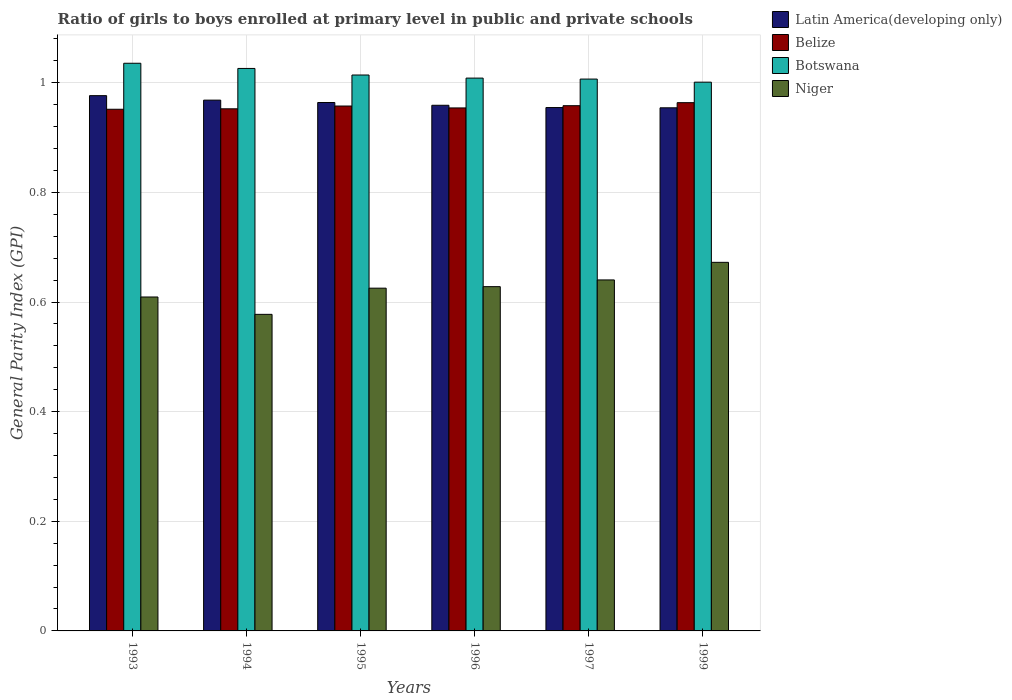How many groups of bars are there?
Make the answer very short. 6. Are the number of bars per tick equal to the number of legend labels?
Give a very brief answer. Yes. In how many cases, is the number of bars for a given year not equal to the number of legend labels?
Keep it short and to the point. 0. What is the general parity index in Latin America(developing only) in 1996?
Your response must be concise. 0.96. Across all years, what is the maximum general parity index in Niger?
Provide a short and direct response. 0.67. Across all years, what is the minimum general parity index in Botswana?
Keep it short and to the point. 1. What is the total general parity index in Latin America(developing only) in the graph?
Your response must be concise. 5.78. What is the difference between the general parity index in Botswana in 1993 and that in 1996?
Keep it short and to the point. 0.03. What is the difference between the general parity index in Niger in 1994 and the general parity index in Belize in 1995?
Offer a terse response. -0.38. What is the average general parity index in Botswana per year?
Keep it short and to the point. 1.02. In the year 1995, what is the difference between the general parity index in Botswana and general parity index in Latin America(developing only)?
Provide a succinct answer. 0.05. In how many years, is the general parity index in Niger greater than 0.32?
Provide a short and direct response. 6. What is the ratio of the general parity index in Latin America(developing only) in 1994 to that in 1999?
Offer a terse response. 1.01. Is the general parity index in Latin America(developing only) in 1993 less than that in 1996?
Offer a terse response. No. Is the difference between the general parity index in Botswana in 1994 and 1999 greater than the difference between the general parity index in Latin America(developing only) in 1994 and 1999?
Your response must be concise. Yes. What is the difference between the highest and the second highest general parity index in Niger?
Keep it short and to the point. 0.03. What is the difference between the highest and the lowest general parity index in Niger?
Your response must be concise. 0.09. Is it the case that in every year, the sum of the general parity index in Belize and general parity index in Botswana is greater than the sum of general parity index in Niger and general parity index in Latin America(developing only)?
Ensure brevity in your answer.  Yes. What does the 4th bar from the left in 1994 represents?
Offer a very short reply. Niger. What does the 2nd bar from the right in 1995 represents?
Give a very brief answer. Botswana. Is it the case that in every year, the sum of the general parity index in Belize and general parity index in Botswana is greater than the general parity index in Niger?
Provide a succinct answer. Yes. Are all the bars in the graph horizontal?
Make the answer very short. No. Does the graph contain grids?
Offer a very short reply. Yes. How are the legend labels stacked?
Your response must be concise. Vertical. What is the title of the graph?
Offer a very short reply. Ratio of girls to boys enrolled at primary level in public and private schools. Does "Europe(developing only)" appear as one of the legend labels in the graph?
Your answer should be compact. No. What is the label or title of the X-axis?
Keep it short and to the point. Years. What is the label or title of the Y-axis?
Make the answer very short. General Parity Index (GPI). What is the General Parity Index (GPI) of Latin America(developing only) in 1993?
Your answer should be very brief. 0.98. What is the General Parity Index (GPI) of Belize in 1993?
Offer a very short reply. 0.95. What is the General Parity Index (GPI) in Botswana in 1993?
Your answer should be very brief. 1.04. What is the General Parity Index (GPI) in Niger in 1993?
Keep it short and to the point. 0.61. What is the General Parity Index (GPI) in Latin America(developing only) in 1994?
Provide a succinct answer. 0.97. What is the General Parity Index (GPI) of Belize in 1994?
Provide a short and direct response. 0.95. What is the General Parity Index (GPI) in Botswana in 1994?
Give a very brief answer. 1.03. What is the General Parity Index (GPI) in Niger in 1994?
Make the answer very short. 0.58. What is the General Parity Index (GPI) in Latin America(developing only) in 1995?
Keep it short and to the point. 0.96. What is the General Parity Index (GPI) in Belize in 1995?
Your answer should be compact. 0.96. What is the General Parity Index (GPI) in Botswana in 1995?
Offer a very short reply. 1.01. What is the General Parity Index (GPI) in Niger in 1995?
Ensure brevity in your answer.  0.63. What is the General Parity Index (GPI) of Latin America(developing only) in 1996?
Offer a very short reply. 0.96. What is the General Parity Index (GPI) of Belize in 1996?
Give a very brief answer. 0.95. What is the General Parity Index (GPI) of Botswana in 1996?
Ensure brevity in your answer.  1.01. What is the General Parity Index (GPI) of Niger in 1996?
Your answer should be compact. 0.63. What is the General Parity Index (GPI) in Latin America(developing only) in 1997?
Make the answer very short. 0.95. What is the General Parity Index (GPI) in Belize in 1997?
Give a very brief answer. 0.96. What is the General Parity Index (GPI) in Botswana in 1997?
Your answer should be compact. 1.01. What is the General Parity Index (GPI) of Niger in 1997?
Offer a very short reply. 0.64. What is the General Parity Index (GPI) of Latin America(developing only) in 1999?
Your answer should be very brief. 0.95. What is the General Parity Index (GPI) of Belize in 1999?
Offer a terse response. 0.96. What is the General Parity Index (GPI) of Botswana in 1999?
Offer a very short reply. 1. What is the General Parity Index (GPI) in Niger in 1999?
Your answer should be very brief. 0.67. Across all years, what is the maximum General Parity Index (GPI) in Latin America(developing only)?
Your response must be concise. 0.98. Across all years, what is the maximum General Parity Index (GPI) of Belize?
Ensure brevity in your answer.  0.96. Across all years, what is the maximum General Parity Index (GPI) in Botswana?
Provide a succinct answer. 1.04. Across all years, what is the maximum General Parity Index (GPI) of Niger?
Your answer should be very brief. 0.67. Across all years, what is the minimum General Parity Index (GPI) in Latin America(developing only)?
Offer a terse response. 0.95. Across all years, what is the minimum General Parity Index (GPI) of Belize?
Give a very brief answer. 0.95. Across all years, what is the minimum General Parity Index (GPI) of Botswana?
Your response must be concise. 1. Across all years, what is the minimum General Parity Index (GPI) of Niger?
Your answer should be compact. 0.58. What is the total General Parity Index (GPI) in Latin America(developing only) in the graph?
Keep it short and to the point. 5.78. What is the total General Parity Index (GPI) in Belize in the graph?
Ensure brevity in your answer.  5.74. What is the total General Parity Index (GPI) in Botswana in the graph?
Your response must be concise. 6.09. What is the total General Parity Index (GPI) of Niger in the graph?
Ensure brevity in your answer.  3.75. What is the difference between the General Parity Index (GPI) in Latin America(developing only) in 1993 and that in 1994?
Your response must be concise. 0.01. What is the difference between the General Parity Index (GPI) in Belize in 1993 and that in 1994?
Provide a short and direct response. -0. What is the difference between the General Parity Index (GPI) in Botswana in 1993 and that in 1994?
Offer a very short reply. 0.01. What is the difference between the General Parity Index (GPI) of Niger in 1993 and that in 1994?
Your answer should be very brief. 0.03. What is the difference between the General Parity Index (GPI) in Latin America(developing only) in 1993 and that in 1995?
Your answer should be very brief. 0.01. What is the difference between the General Parity Index (GPI) of Belize in 1993 and that in 1995?
Your answer should be very brief. -0.01. What is the difference between the General Parity Index (GPI) in Botswana in 1993 and that in 1995?
Offer a very short reply. 0.02. What is the difference between the General Parity Index (GPI) in Niger in 1993 and that in 1995?
Keep it short and to the point. -0.02. What is the difference between the General Parity Index (GPI) in Latin America(developing only) in 1993 and that in 1996?
Offer a terse response. 0.02. What is the difference between the General Parity Index (GPI) in Belize in 1993 and that in 1996?
Offer a terse response. -0. What is the difference between the General Parity Index (GPI) of Botswana in 1993 and that in 1996?
Provide a short and direct response. 0.03. What is the difference between the General Parity Index (GPI) of Niger in 1993 and that in 1996?
Your response must be concise. -0.02. What is the difference between the General Parity Index (GPI) in Latin America(developing only) in 1993 and that in 1997?
Ensure brevity in your answer.  0.02. What is the difference between the General Parity Index (GPI) of Belize in 1993 and that in 1997?
Provide a succinct answer. -0.01. What is the difference between the General Parity Index (GPI) in Botswana in 1993 and that in 1997?
Your answer should be compact. 0.03. What is the difference between the General Parity Index (GPI) of Niger in 1993 and that in 1997?
Offer a terse response. -0.03. What is the difference between the General Parity Index (GPI) in Latin America(developing only) in 1993 and that in 1999?
Your answer should be compact. 0.02. What is the difference between the General Parity Index (GPI) of Belize in 1993 and that in 1999?
Provide a short and direct response. -0.01. What is the difference between the General Parity Index (GPI) in Botswana in 1993 and that in 1999?
Your answer should be very brief. 0.03. What is the difference between the General Parity Index (GPI) of Niger in 1993 and that in 1999?
Offer a terse response. -0.06. What is the difference between the General Parity Index (GPI) in Latin America(developing only) in 1994 and that in 1995?
Your answer should be very brief. 0. What is the difference between the General Parity Index (GPI) in Belize in 1994 and that in 1995?
Make the answer very short. -0.01. What is the difference between the General Parity Index (GPI) of Botswana in 1994 and that in 1995?
Keep it short and to the point. 0.01. What is the difference between the General Parity Index (GPI) in Niger in 1994 and that in 1995?
Keep it short and to the point. -0.05. What is the difference between the General Parity Index (GPI) in Latin America(developing only) in 1994 and that in 1996?
Your answer should be very brief. 0.01. What is the difference between the General Parity Index (GPI) of Belize in 1994 and that in 1996?
Keep it short and to the point. -0. What is the difference between the General Parity Index (GPI) in Botswana in 1994 and that in 1996?
Your answer should be very brief. 0.02. What is the difference between the General Parity Index (GPI) of Niger in 1994 and that in 1996?
Your response must be concise. -0.05. What is the difference between the General Parity Index (GPI) of Latin America(developing only) in 1994 and that in 1997?
Provide a succinct answer. 0.01. What is the difference between the General Parity Index (GPI) of Belize in 1994 and that in 1997?
Your response must be concise. -0.01. What is the difference between the General Parity Index (GPI) of Botswana in 1994 and that in 1997?
Make the answer very short. 0.02. What is the difference between the General Parity Index (GPI) in Niger in 1994 and that in 1997?
Your response must be concise. -0.06. What is the difference between the General Parity Index (GPI) in Latin America(developing only) in 1994 and that in 1999?
Your response must be concise. 0.01. What is the difference between the General Parity Index (GPI) in Belize in 1994 and that in 1999?
Give a very brief answer. -0.01. What is the difference between the General Parity Index (GPI) in Botswana in 1994 and that in 1999?
Offer a terse response. 0.03. What is the difference between the General Parity Index (GPI) of Niger in 1994 and that in 1999?
Provide a short and direct response. -0.09. What is the difference between the General Parity Index (GPI) in Latin America(developing only) in 1995 and that in 1996?
Give a very brief answer. 0.01. What is the difference between the General Parity Index (GPI) in Belize in 1995 and that in 1996?
Keep it short and to the point. 0. What is the difference between the General Parity Index (GPI) in Botswana in 1995 and that in 1996?
Make the answer very short. 0.01. What is the difference between the General Parity Index (GPI) in Niger in 1995 and that in 1996?
Your answer should be very brief. -0. What is the difference between the General Parity Index (GPI) in Latin America(developing only) in 1995 and that in 1997?
Your answer should be very brief. 0.01. What is the difference between the General Parity Index (GPI) in Belize in 1995 and that in 1997?
Your answer should be compact. -0. What is the difference between the General Parity Index (GPI) of Botswana in 1995 and that in 1997?
Provide a succinct answer. 0.01. What is the difference between the General Parity Index (GPI) in Niger in 1995 and that in 1997?
Your response must be concise. -0.01. What is the difference between the General Parity Index (GPI) in Latin America(developing only) in 1995 and that in 1999?
Offer a very short reply. 0.01. What is the difference between the General Parity Index (GPI) of Belize in 1995 and that in 1999?
Your response must be concise. -0.01. What is the difference between the General Parity Index (GPI) in Botswana in 1995 and that in 1999?
Offer a terse response. 0.01. What is the difference between the General Parity Index (GPI) in Niger in 1995 and that in 1999?
Ensure brevity in your answer.  -0.05. What is the difference between the General Parity Index (GPI) of Latin America(developing only) in 1996 and that in 1997?
Offer a terse response. 0. What is the difference between the General Parity Index (GPI) of Belize in 1996 and that in 1997?
Offer a very short reply. -0. What is the difference between the General Parity Index (GPI) in Botswana in 1996 and that in 1997?
Make the answer very short. 0. What is the difference between the General Parity Index (GPI) in Niger in 1996 and that in 1997?
Keep it short and to the point. -0.01. What is the difference between the General Parity Index (GPI) of Latin America(developing only) in 1996 and that in 1999?
Your answer should be very brief. 0. What is the difference between the General Parity Index (GPI) in Belize in 1996 and that in 1999?
Offer a terse response. -0.01. What is the difference between the General Parity Index (GPI) in Botswana in 1996 and that in 1999?
Give a very brief answer. 0.01. What is the difference between the General Parity Index (GPI) in Niger in 1996 and that in 1999?
Your answer should be very brief. -0.04. What is the difference between the General Parity Index (GPI) of Belize in 1997 and that in 1999?
Give a very brief answer. -0.01. What is the difference between the General Parity Index (GPI) in Botswana in 1997 and that in 1999?
Provide a succinct answer. 0.01. What is the difference between the General Parity Index (GPI) in Niger in 1997 and that in 1999?
Make the answer very short. -0.03. What is the difference between the General Parity Index (GPI) of Latin America(developing only) in 1993 and the General Parity Index (GPI) of Belize in 1994?
Offer a very short reply. 0.02. What is the difference between the General Parity Index (GPI) of Latin America(developing only) in 1993 and the General Parity Index (GPI) of Botswana in 1994?
Your answer should be very brief. -0.05. What is the difference between the General Parity Index (GPI) of Latin America(developing only) in 1993 and the General Parity Index (GPI) of Niger in 1994?
Provide a succinct answer. 0.4. What is the difference between the General Parity Index (GPI) of Belize in 1993 and the General Parity Index (GPI) of Botswana in 1994?
Offer a very short reply. -0.07. What is the difference between the General Parity Index (GPI) of Belize in 1993 and the General Parity Index (GPI) of Niger in 1994?
Your response must be concise. 0.37. What is the difference between the General Parity Index (GPI) in Botswana in 1993 and the General Parity Index (GPI) in Niger in 1994?
Your answer should be compact. 0.46. What is the difference between the General Parity Index (GPI) of Latin America(developing only) in 1993 and the General Parity Index (GPI) of Belize in 1995?
Provide a short and direct response. 0.02. What is the difference between the General Parity Index (GPI) in Latin America(developing only) in 1993 and the General Parity Index (GPI) in Botswana in 1995?
Give a very brief answer. -0.04. What is the difference between the General Parity Index (GPI) of Latin America(developing only) in 1993 and the General Parity Index (GPI) of Niger in 1995?
Your response must be concise. 0.35. What is the difference between the General Parity Index (GPI) of Belize in 1993 and the General Parity Index (GPI) of Botswana in 1995?
Keep it short and to the point. -0.06. What is the difference between the General Parity Index (GPI) in Belize in 1993 and the General Parity Index (GPI) in Niger in 1995?
Give a very brief answer. 0.33. What is the difference between the General Parity Index (GPI) of Botswana in 1993 and the General Parity Index (GPI) of Niger in 1995?
Offer a very short reply. 0.41. What is the difference between the General Parity Index (GPI) of Latin America(developing only) in 1993 and the General Parity Index (GPI) of Belize in 1996?
Make the answer very short. 0.02. What is the difference between the General Parity Index (GPI) in Latin America(developing only) in 1993 and the General Parity Index (GPI) in Botswana in 1996?
Offer a very short reply. -0.03. What is the difference between the General Parity Index (GPI) of Latin America(developing only) in 1993 and the General Parity Index (GPI) of Niger in 1996?
Keep it short and to the point. 0.35. What is the difference between the General Parity Index (GPI) of Belize in 1993 and the General Parity Index (GPI) of Botswana in 1996?
Provide a succinct answer. -0.06. What is the difference between the General Parity Index (GPI) of Belize in 1993 and the General Parity Index (GPI) of Niger in 1996?
Your answer should be very brief. 0.32. What is the difference between the General Parity Index (GPI) in Botswana in 1993 and the General Parity Index (GPI) in Niger in 1996?
Provide a succinct answer. 0.41. What is the difference between the General Parity Index (GPI) in Latin America(developing only) in 1993 and the General Parity Index (GPI) in Belize in 1997?
Provide a short and direct response. 0.02. What is the difference between the General Parity Index (GPI) of Latin America(developing only) in 1993 and the General Parity Index (GPI) of Botswana in 1997?
Give a very brief answer. -0.03. What is the difference between the General Parity Index (GPI) of Latin America(developing only) in 1993 and the General Parity Index (GPI) of Niger in 1997?
Your answer should be compact. 0.34. What is the difference between the General Parity Index (GPI) in Belize in 1993 and the General Parity Index (GPI) in Botswana in 1997?
Provide a succinct answer. -0.06. What is the difference between the General Parity Index (GPI) of Belize in 1993 and the General Parity Index (GPI) of Niger in 1997?
Your answer should be very brief. 0.31. What is the difference between the General Parity Index (GPI) of Botswana in 1993 and the General Parity Index (GPI) of Niger in 1997?
Offer a very short reply. 0.4. What is the difference between the General Parity Index (GPI) in Latin America(developing only) in 1993 and the General Parity Index (GPI) in Belize in 1999?
Provide a short and direct response. 0.01. What is the difference between the General Parity Index (GPI) of Latin America(developing only) in 1993 and the General Parity Index (GPI) of Botswana in 1999?
Make the answer very short. -0.02. What is the difference between the General Parity Index (GPI) of Latin America(developing only) in 1993 and the General Parity Index (GPI) of Niger in 1999?
Offer a very short reply. 0.3. What is the difference between the General Parity Index (GPI) in Belize in 1993 and the General Parity Index (GPI) in Botswana in 1999?
Offer a very short reply. -0.05. What is the difference between the General Parity Index (GPI) of Belize in 1993 and the General Parity Index (GPI) of Niger in 1999?
Your answer should be compact. 0.28. What is the difference between the General Parity Index (GPI) of Botswana in 1993 and the General Parity Index (GPI) of Niger in 1999?
Your answer should be very brief. 0.36. What is the difference between the General Parity Index (GPI) in Latin America(developing only) in 1994 and the General Parity Index (GPI) in Belize in 1995?
Make the answer very short. 0.01. What is the difference between the General Parity Index (GPI) of Latin America(developing only) in 1994 and the General Parity Index (GPI) of Botswana in 1995?
Ensure brevity in your answer.  -0.05. What is the difference between the General Parity Index (GPI) of Latin America(developing only) in 1994 and the General Parity Index (GPI) of Niger in 1995?
Provide a succinct answer. 0.34. What is the difference between the General Parity Index (GPI) of Belize in 1994 and the General Parity Index (GPI) of Botswana in 1995?
Offer a very short reply. -0.06. What is the difference between the General Parity Index (GPI) of Belize in 1994 and the General Parity Index (GPI) of Niger in 1995?
Keep it short and to the point. 0.33. What is the difference between the General Parity Index (GPI) in Botswana in 1994 and the General Parity Index (GPI) in Niger in 1995?
Make the answer very short. 0.4. What is the difference between the General Parity Index (GPI) of Latin America(developing only) in 1994 and the General Parity Index (GPI) of Belize in 1996?
Provide a succinct answer. 0.01. What is the difference between the General Parity Index (GPI) of Latin America(developing only) in 1994 and the General Parity Index (GPI) of Botswana in 1996?
Offer a terse response. -0.04. What is the difference between the General Parity Index (GPI) in Latin America(developing only) in 1994 and the General Parity Index (GPI) in Niger in 1996?
Offer a very short reply. 0.34. What is the difference between the General Parity Index (GPI) of Belize in 1994 and the General Parity Index (GPI) of Botswana in 1996?
Ensure brevity in your answer.  -0.06. What is the difference between the General Parity Index (GPI) in Belize in 1994 and the General Parity Index (GPI) in Niger in 1996?
Ensure brevity in your answer.  0.32. What is the difference between the General Parity Index (GPI) of Botswana in 1994 and the General Parity Index (GPI) of Niger in 1996?
Ensure brevity in your answer.  0.4. What is the difference between the General Parity Index (GPI) in Latin America(developing only) in 1994 and the General Parity Index (GPI) in Belize in 1997?
Provide a succinct answer. 0.01. What is the difference between the General Parity Index (GPI) of Latin America(developing only) in 1994 and the General Parity Index (GPI) of Botswana in 1997?
Ensure brevity in your answer.  -0.04. What is the difference between the General Parity Index (GPI) in Latin America(developing only) in 1994 and the General Parity Index (GPI) in Niger in 1997?
Provide a succinct answer. 0.33. What is the difference between the General Parity Index (GPI) in Belize in 1994 and the General Parity Index (GPI) in Botswana in 1997?
Provide a succinct answer. -0.05. What is the difference between the General Parity Index (GPI) in Belize in 1994 and the General Parity Index (GPI) in Niger in 1997?
Keep it short and to the point. 0.31. What is the difference between the General Parity Index (GPI) in Botswana in 1994 and the General Parity Index (GPI) in Niger in 1997?
Offer a terse response. 0.39. What is the difference between the General Parity Index (GPI) in Latin America(developing only) in 1994 and the General Parity Index (GPI) in Belize in 1999?
Your answer should be compact. 0. What is the difference between the General Parity Index (GPI) of Latin America(developing only) in 1994 and the General Parity Index (GPI) of Botswana in 1999?
Offer a very short reply. -0.03. What is the difference between the General Parity Index (GPI) in Latin America(developing only) in 1994 and the General Parity Index (GPI) in Niger in 1999?
Make the answer very short. 0.3. What is the difference between the General Parity Index (GPI) of Belize in 1994 and the General Parity Index (GPI) of Botswana in 1999?
Keep it short and to the point. -0.05. What is the difference between the General Parity Index (GPI) of Belize in 1994 and the General Parity Index (GPI) of Niger in 1999?
Your answer should be very brief. 0.28. What is the difference between the General Parity Index (GPI) in Botswana in 1994 and the General Parity Index (GPI) in Niger in 1999?
Offer a terse response. 0.35. What is the difference between the General Parity Index (GPI) in Latin America(developing only) in 1995 and the General Parity Index (GPI) in Belize in 1996?
Your answer should be very brief. 0.01. What is the difference between the General Parity Index (GPI) of Latin America(developing only) in 1995 and the General Parity Index (GPI) of Botswana in 1996?
Your answer should be very brief. -0.04. What is the difference between the General Parity Index (GPI) in Latin America(developing only) in 1995 and the General Parity Index (GPI) in Niger in 1996?
Offer a very short reply. 0.34. What is the difference between the General Parity Index (GPI) in Belize in 1995 and the General Parity Index (GPI) in Botswana in 1996?
Offer a terse response. -0.05. What is the difference between the General Parity Index (GPI) of Belize in 1995 and the General Parity Index (GPI) of Niger in 1996?
Keep it short and to the point. 0.33. What is the difference between the General Parity Index (GPI) in Botswana in 1995 and the General Parity Index (GPI) in Niger in 1996?
Offer a very short reply. 0.39. What is the difference between the General Parity Index (GPI) in Latin America(developing only) in 1995 and the General Parity Index (GPI) in Belize in 1997?
Offer a terse response. 0.01. What is the difference between the General Parity Index (GPI) of Latin America(developing only) in 1995 and the General Parity Index (GPI) of Botswana in 1997?
Offer a terse response. -0.04. What is the difference between the General Parity Index (GPI) in Latin America(developing only) in 1995 and the General Parity Index (GPI) in Niger in 1997?
Offer a terse response. 0.32. What is the difference between the General Parity Index (GPI) in Belize in 1995 and the General Parity Index (GPI) in Botswana in 1997?
Give a very brief answer. -0.05. What is the difference between the General Parity Index (GPI) in Belize in 1995 and the General Parity Index (GPI) in Niger in 1997?
Your answer should be compact. 0.32. What is the difference between the General Parity Index (GPI) of Botswana in 1995 and the General Parity Index (GPI) of Niger in 1997?
Your response must be concise. 0.37. What is the difference between the General Parity Index (GPI) of Latin America(developing only) in 1995 and the General Parity Index (GPI) of Belize in 1999?
Provide a short and direct response. 0. What is the difference between the General Parity Index (GPI) of Latin America(developing only) in 1995 and the General Parity Index (GPI) of Botswana in 1999?
Make the answer very short. -0.04. What is the difference between the General Parity Index (GPI) in Latin America(developing only) in 1995 and the General Parity Index (GPI) in Niger in 1999?
Your answer should be compact. 0.29. What is the difference between the General Parity Index (GPI) in Belize in 1995 and the General Parity Index (GPI) in Botswana in 1999?
Offer a terse response. -0.04. What is the difference between the General Parity Index (GPI) of Belize in 1995 and the General Parity Index (GPI) of Niger in 1999?
Keep it short and to the point. 0.29. What is the difference between the General Parity Index (GPI) of Botswana in 1995 and the General Parity Index (GPI) of Niger in 1999?
Your answer should be very brief. 0.34. What is the difference between the General Parity Index (GPI) in Latin America(developing only) in 1996 and the General Parity Index (GPI) in Belize in 1997?
Make the answer very short. 0. What is the difference between the General Parity Index (GPI) in Latin America(developing only) in 1996 and the General Parity Index (GPI) in Botswana in 1997?
Give a very brief answer. -0.05. What is the difference between the General Parity Index (GPI) of Latin America(developing only) in 1996 and the General Parity Index (GPI) of Niger in 1997?
Offer a terse response. 0.32. What is the difference between the General Parity Index (GPI) of Belize in 1996 and the General Parity Index (GPI) of Botswana in 1997?
Offer a very short reply. -0.05. What is the difference between the General Parity Index (GPI) in Belize in 1996 and the General Parity Index (GPI) in Niger in 1997?
Offer a terse response. 0.31. What is the difference between the General Parity Index (GPI) in Botswana in 1996 and the General Parity Index (GPI) in Niger in 1997?
Your answer should be very brief. 0.37. What is the difference between the General Parity Index (GPI) in Latin America(developing only) in 1996 and the General Parity Index (GPI) in Belize in 1999?
Make the answer very short. -0. What is the difference between the General Parity Index (GPI) in Latin America(developing only) in 1996 and the General Parity Index (GPI) in Botswana in 1999?
Offer a very short reply. -0.04. What is the difference between the General Parity Index (GPI) in Latin America(developing only) in 1996 and the General Parity Index (GPI) in Niger in 1999?
Make the answer very short. 0.29. What is the difference between the General Parity Index (GPI) in Belize in 1996 and the General Parity Index (GPI) in Botswana in 1999?
Offer a terse response. -0.05. What is the difference between the General Parity Index (GPI) of Belize in 1996 and the General Parity Index (GPI) of Niger in 1999?
Your response must be concise. 0.28. What is the difference between the General Parity Index (GPI) in Botswana in 1996 and the General Parity Index (GPI) in Niger in 1999?
Your response must be concise. 0.34. What is the difference between the General Parity Index (GPI) in Latin America(developing only) in 1997 and the General Parity Index (GPI) in Belize in 1999?
Offer a very short reply. -0.01. What is the difference between the General Parity Index (GPI) in Latin America(developing only) in 1997 and the General Parity Index (GPI) in Botswana in 1999?
Offer a very short reply. -0.05. What is the difference between the General Parity Index (GPI) of Latin America(developing only) in 1997 and the General Parity Index (GPI) of Niger in 1999?
Ensure brevity in your answer.  0.28. What is the difference between the General Parity Index (GPI) of Belize in 1997 and the General Parity Index (GPI) of Botswana in 1999?
Your response must be concise. -0.04. What is the difference between the General Parity Index (GPI) in Belize in 1997 and the General Parity Index (GPI) in Niger in 1999?
Provide a succinct answer. 0.29. What is the difference between the General Parity Index (GPI) of Botswana in 1997 and the General Parity Index (GPI) of Niger in 1999?
Provide a succinct answer. 0.33. What is the average General Parity Index (GPI) of Latin America(developing only) per year?
Provide a succinct answer. 0.96. What is the average General Parity Index (GPI) of Belize per year?
Your response must be concise. 0.96. What is the average General Parity Index (GPI) in Botswana per year?
Provide a succinct answer. 1.02. What is the average General Parity Index (GPI) of Niger per year?
Provide a short and direct response. 0.63. In the year 1993, what is the difference between the General Parity Index (GPI) of Latin America(developing only) and General Parity Index (GPI) of Belize?
Provide a succinct answer. 0.02. In the year 1993, what is the difference between the General Parity Index (GPI) in Latin America(developing only) and General Parity Index (GPI) in Botswana?
Keep it short and to the point. -0.06. In the year 1993, what is the difference between the General Parity Index (GPI) of Latin America(developing only) and General Parity Index (GPI) of Niger?
Give a very brief answer. 0.37. In the year 1993, what is the difference between the General Parity Index (GPI) in Belize and General Parity Index (GPI) in Botswana?
Make the answer very short. -0.08. In the year 1993, what is the difference between the General Parity Index (GPI) in Belize and General Parity Index (GPI) in Niger?
Your answer should be very brief. 0.34. In the year 1993, what is the difference between the General Parity Index (GPI) of Botswana and General Parity Index (GPI) of Niger?
Provide a short and direct response. 0.43. In the year 1994, what is the difference between the General Parity Index (GPI) of Latin America(developing only) and General Parity Index (GPI) of Belize?
Provide a succinct answer. 0.02. In the year 1994, what is the difference between the General Parity Index (GPI) in Latin America(developing only) and General Parity Index (GPI) in Botswana?
Provide a succinct answer. -0.06. In the year 1994, what is the difference between the General Parity Index (GPI) of Latin America(developing only) and General Parity Index (GPI) of Niger?
Make the answer very short. 0.39. In the year 1994, what is the difference between the General Parity Index (GPI) of Belize and General Parity Index (GPI) of Botswana?
Keep it short and to the point. -0.07. In the year 1994, what is the difference between the General Parity Index (GPI) in Belize and General Parity Index (GPI) in Niger?
Offer a very short reply. 0.38. In the year 1994, what is the difference between the General Parity Index (GPI) in Botswana and General Parity Index (GPI) in Niger?
Give a very brief answer. 0.45. In the year 1995, what is the difference between the General Parity Index (GPI) of Latin America(developing only) and General Parity Index (GPI) of Belize?
Keep it short and to the point. 0.01. In the year 1995, what is the difference between the General Parity Index (GPI) in Latin America(developing only) and General Parity Index (GPI) in Botswana?
Your response must be concise. -0.05. In the year 1995, what is the difference between the General Parity Index (GPI) in Latin America(developing only) and General Parity Index (GPI) in Niger?
Offer a very short reply. 0.34. In the year 1995, what is the difference between the General Parity Index (GPI) in Belize and General Parity Index (GPI) in Botswana?
Offer a very short reply. -0.06. In the year 1995, what is the difference between the General Parity Index (GPI) of Belize and General Parity Index (GPI) of Niger?
Provide a succinct answer. 0.33. In the year 1995, what is the difference between the General Parity Index (GPI) in Botswana and General Parity Index (GPI) in Niger?
Give a very brief answer. 0.39. In the year 1996, what is the difference between the General Parity Index (GPI) of Latin America(developing only) and General Parity Index (GPI) of Belize?
Ensure brevity in your answer.  0. In the year 1996, what is the difference between the General Parity Index (GPI) in Latin America(developing only) and General Parity Index (GPI) in Botswana?
Your answer should be very brief. -0.05. In the year 1996, what is the difference between the General Parity Index (GPI) of Latin America(developing only) and General Parity Index (GPI) of Niger?
Your answer should be compact. 0.33. In the year 1996, what is the difference between the General Parity Index (GPI) in Belize and General Parity Index (GPI) in Botswana?
Offer a very short reply. -0.05. In the year 1996, what is the difference between the General Parity Index (GPI) of Belize and General Parity Index (GPI) of Niger?
Your answer should be very brief. 0.33. In the year 1996, what is the difference between the General Parity Index (GPI) in Botswana and General Parity Index (GPI) in Niger?
Your answer should be compact. 0.38. In the year 1997, what is the difference between the General Parity Index (GPI) of Latin America(developing only) and General Parity Index (GPI) of Belize?
Ensure brevity in your answer.  -0. In the year 1997, what is the difference between the General Parity Index (GPI) in Latin America(developing only) and General Parity Index (GPI) in Botswana?
Offer a very short reply. -0.05. In the year 1997, what is the difference between the General Parity Index (GPI) in Latin America(developing only) and General Parity Index (GPI) in Niger?
Make the answer very short. 0.31. In the year 1997, what is the difference between the General Parity Index (GPI) of Belize and General Parity Index (GPI) of Botswana?
Provide a short and direct response. -0.05. In the year 1997, what is the difference between the General Parity Index (GPI) of Belize and General Parity Index (GPI) of Niger?
Give a very brief answer. 0.32. In the year 1997, what is the difference between the General Parity Index (GPI) of Botswana and General Parity Index (GPI) of Niger?
Give a very brief answer. 0.37. In the year 1999, what is the difference between the General Parity Index (GPI) of Latin America(developing only) and General Parity Index (GPI) of Belize?
Your answer should be very brief. -0.01. In the year 1999, what is the difference between the General Parity Index (GPI) in Latin America(developing only) and General Parity Index (GPI) in Botswana?
Your answer should be very brief. -0.05. In the year 1999, what is the difference between the General Parity Index (GPI) in Latin America(developing only) and General Parity Index (GPI) in Niger?
Your answer should be compact. 0.28. In the year 1999, what is the difference between the General Parity Index (GPI) of Belize and General Parity Index (GPI) of Botswana?
Make the answer very short. -0.04. In the year 1999, what is the difference between the General Parity Index (GPI) of Belize and General Parity Index (GPI) of Niger?
Make the answer very short. 0.29. In the year 1999, what is the difference between the General Parity Index (GPI) of Botswana and General Parity Index (GPI) of Niger?
Your answer should be compact. 0.33. What is the ratio of the General Parity Index (GPI) of Latin America(developing only) in 1993 to that in 1994?
Make the answer very short. 1.01. What is the ratio of the General Parity Index (GPI) of Botswana in 1993 to that in 1994?
Keep it short and to the point. 1.01. What is the ratio of the General Parity Index (GPI) in Niger in 1993 to that in 1994?
Make the answer very short. 1.05. What is the ratio of the General Parity Index (GPI) of Botswana in 1993 to that in 1995?
Your answer should be very brief. 1.02. What is the ratio of the General Parity Index (GPI) of Niger in 1993 to that in 1995?
Your response must be concise. 0.97. What is the ratio of the General Parity Index (GPI) in Latin America(developing only) in 1993 to that in 1996?
Give a very brief answer. 1.02. What is the ratio of the General Parity Index (GPI) of Botswana in 1993 to that in 1996?
Offer a very short reply. 1.03. What is the ratio of the General Parity Index (GPI) in Niger in 1993 to that in 1996?
Offer a terse response. 0.97. What is the ratio of the General Parity Index (GPI) of Latin America(developing only) in 1993 to that in 1997?
Give a very brief answer. 1.02. What is the ratio of the General Parity Index (GPI) in Botswana in 1993 to that in 1997?
Your response must be concise. 1.03. What is the ratio of the General Parity Index (GPI) in Niger in 1993 to that in 1997?
Your answer should be very brief. 0.95. What is the ratio of the General Parity Index (GPI) in Latin America(developing only) in 1993 to that in 1999?
Make the answer very short. 1.02. What is the ratio of the General Parity Index (GPI) in Belize in 1993 to that in 1999?
Your answer should be compact. 0.99. What is the ratio of the General Parity Index (GPI) in Botswana in 1993 to that in 1999?
Offer a terse response. 1.03. What is the ratio of the General Parity Index (GPI) in Niger in 1993 to that in 1999?
Offer a very short reply. 0.91. What is the ratio of the General Parity Index (GPI) in Latin America(developing only) in 1994 to that in 1995?
Provide a short and direct response. 1. What is the ratio of the General Parity Index (GPI) in Belize in 1994 to that in 1995?
Your response must be concise. 0.99. What is the ratio of the General Parity Index (GPI) in Botswana in 1994 to that in 1995?
Offer a very short reply. 1.01. What is the ratio of the General Parity Index (GPI) of Niger in 1994 to that in 1995?
Your answer should be compact. 0.92. What is the ratio of the General Parity Index (GPI) in Latin America(developing only) in 1994 to that in 1996?
Ensure brevity in your answer.  1.01. What is the ratio of the General Parity Index (GPI) in Belize in 1994 to that in 1996?
Your answer should be very brief. 1. What is the ratio of the General Parity Index (GPI) in Botswana in 1994 to that in 1996?
Make the answer very short. 1.02. What is the ratio of the General Parity Index (GPI) of Niger in 1994 to that in 1996?
Provide a succinct answer. 0.92. What is the ratio of the General Parity Index (GPI) in Latin America(developing only) in 1994 to that in 1997?
Offer a terse response. 1.01. What is the ratio of the General Parity Index (GPI) of Belize in 1994 to that in 1997?
Your answer should be compact. 0.99. What is the ratio of the General Parity Index (GPI) in Botswana in 1994 to that in 1997?
Your answer should be compact. 1.02. What is the ratio of the General Parity Index (GPI) in Niger in 1994 to that in 1997?
Make the answer very short. 0.9. What is the ratio of the General Parity Index (GPI) of Latin America(developing only) in 1994 to that in 1999?
Provide a short and direct response. 1.01. What is the ratio of the General Parity Index (GPI) in Belize in 1994 to that in 1999?
Offer a very short reply. 0.99. What is the ratio of the General Parity Index (GPI) of Niger in 1994 to that in 1999?
Make the answer very short. 0.86. What is the ratio of the General Parity Index (GPI) in Latin America(developing only) in 1995 to that in 1996?
Offer a terse response. 1.01. What is the ratio of the General Parity Index (GPI) of Botswana in 1995 to that in 1996?
Your answer should be very brief. 1.01. What is the ratio of the General Parity Index (GPI) of Latin America(developing only) in 1995 to that in 1997?
Make the answer very short. 1.01. What is the ratio of the General Parity Index (GPI) in Botswana in 1995 to that in 1997?
Your answer should be very brief. 1.01. What is the ratio of the General Parity Index (GPI) of Niger in 1995 to that in 1997?
Make the answer very short. 0.98. What is the ratio of the General Parity Index (GPI) of Belize in 1995 to that in 1999?
Provide a succinct answer. 0.99. What is the ratio of the General Parity Index (GPI) in Botswana in 1995 to that in 1999?
Give a very brief answer. 1.01. What is the ratio of the General Parity Index (GPI) in Niger in 1995 to that in 1999?
Your answer should be very brief. 0.93. What is the ratio of the General Parity Index (GPI) of Latin America(developing only) in 1996 to that in 1997?
Make the answer very short. 1. What is the ratio of the General Parity Index (GPI) of Belize in 1996 to that in 1997?
Offer a terse response. 1. What is the ratio of the General Parity Index (GPI) of Niger in 1996 to that in 1997?
Your answer should be compact. 0.98. What is the ratio of the General Parity Index (GPI) of Latin America(developing only) in 1996 to that in 1999?
Give a very brief answer. 1. What is the ratio of the General Parity Index (GPI) in Belize in 1996 to that in 1999?
Offer a very short reply. 0.99. What is the ratio of the General Parity Index (GPI) in Botswana in 1996 to that in 1999?
Your answer should be compact. 1.01. What is the ratio of the General Parity Index (GPI) of Niger in 1996 to that in 1999?
Provide a short and direct response. 0.93. What is the ratio of the General Parity Index (GPI) of Latin America(developing only) in 1997 to that in 1999?
Ensure brevity in your answer.  1. What is the ratio of the General Parity Index (GPI) in Belize in 1997 to that in 1999?
Give a very brief answer. 0.99. What is the ratio of the General Parity Index (GPI) in Botswana in 1997 to that in 1999?
Your answer should be very brief. 1.01. What is the ratio of the General Parity Index (GPI) in Niger in 1997 to that in 1999?
Ensure brevity in your answer.  0.95. What is the difference between the highest and the second highest General Parity Index (GPI) of Latin America(developing only)?
Ensure brevity in your answer.  0.01. What is the difference between the highest and the second highest General Parity Index (GPI) in Belize?
Give a very brief answer. 0.01. What is the difference between the highest and the second highest General Parity Index (GPI) of Botswana?
Offer a terse response. 0.01. What is the difference between the highest and the second highest General Parity Index (GPI) in Niger?
Give a very brief answer. 0.03. What is the difference between the highest and the lowest General Parity Index (GPI) of Latin America(developing only)?
Make the answer very short. 0.02. What is the difference between the highest and the lowest General Parity Index (GPI) of Belize?
Make the answer very short. 0.01. What is the difference between the highest and the lowest General Parity Index (GPI) of Botswana?
Provide a succinct answer. 0.03. What is the difference between the highest and the lowest General Parity Index (GPI) in Niger?
Offer a very short reply. 0.09. 